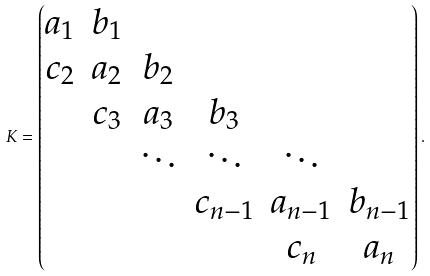<formula> <loc_0><loc_0><loc_500><loc_500>K = \begin{pmatrix} a _ { 1 } & b _ { 1 } \\ c _ { 2 } & a _ { 2 } & b _ { 2 } \\ & c _ { 3 } & a _ { 3 } & b _ { 3 } \\ & & \ddots & \ddots & \ddots \\ & & & c _ { n - 1 } & a _ { n - 1 } & b _ { n - 1 } \\ & & & & c _ { n } & a _ { n } \end{pmatrix} .</formula> 